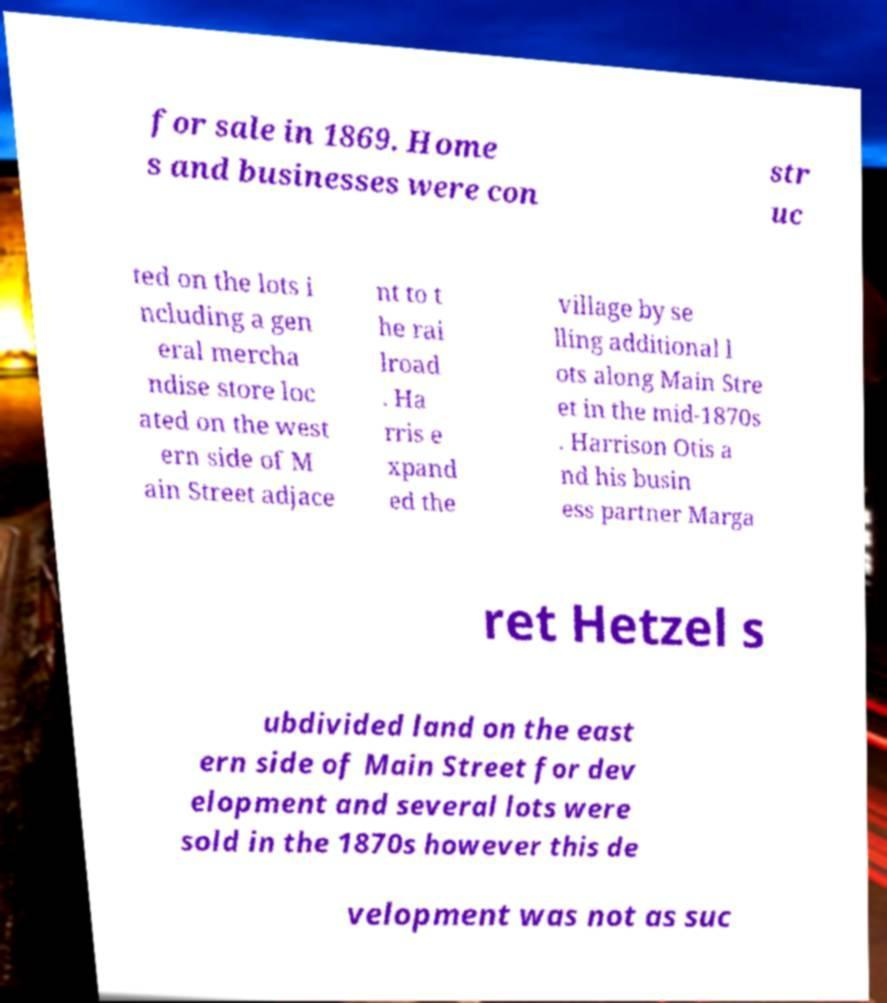I need the written content from this picture converted into text. Can you do that? for sale in 1869. Home s and businesses were con str uc ted on the lots i ncluding a gen eral mercha ndise store loc ated on the west ern side of M ain Street adjace nt to t he rai lroad . Ha rris e xpand ed the village by se lling additional l ots along Main Stre et in the mid-1870s . Harrison Otis a nd his busin ess partner Marga ret Hetzel s ubdivided land on the east ern side of Main Street for dev elopment and several lots were sold in the 1870s however this de velopment was not as suc 